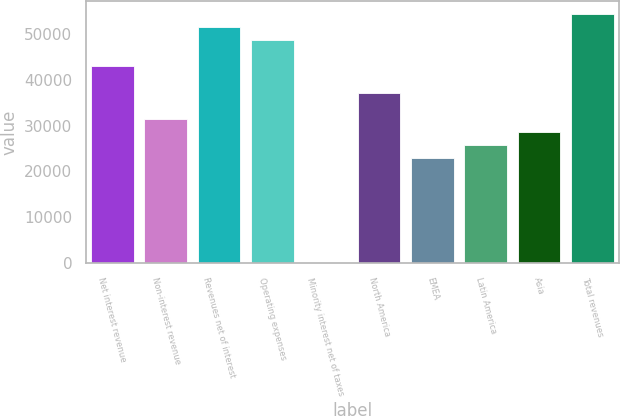Convert chart. <chart><loc_0><loc_0><loc_500><loc_500><bar_chart><fcel>Net interest revenue<fcel>Non-interest revenue<fcel>Revenues net of interest<fcel>Operating expenses<fcel>Minority interest net of taxes<fcel>North America<fcel>EMEA<fcel>Latin America<fcel>Asia<fcel>Total revenues<nl><fcel>42972.5<fcel>31516.1<fcel>51564.8<fcel>48700.7<fcel>11<fcel>37244.3<fcel>22923.8<fcel>25787.9<fcel>28652<fcel>54428.9<nl></chart> 